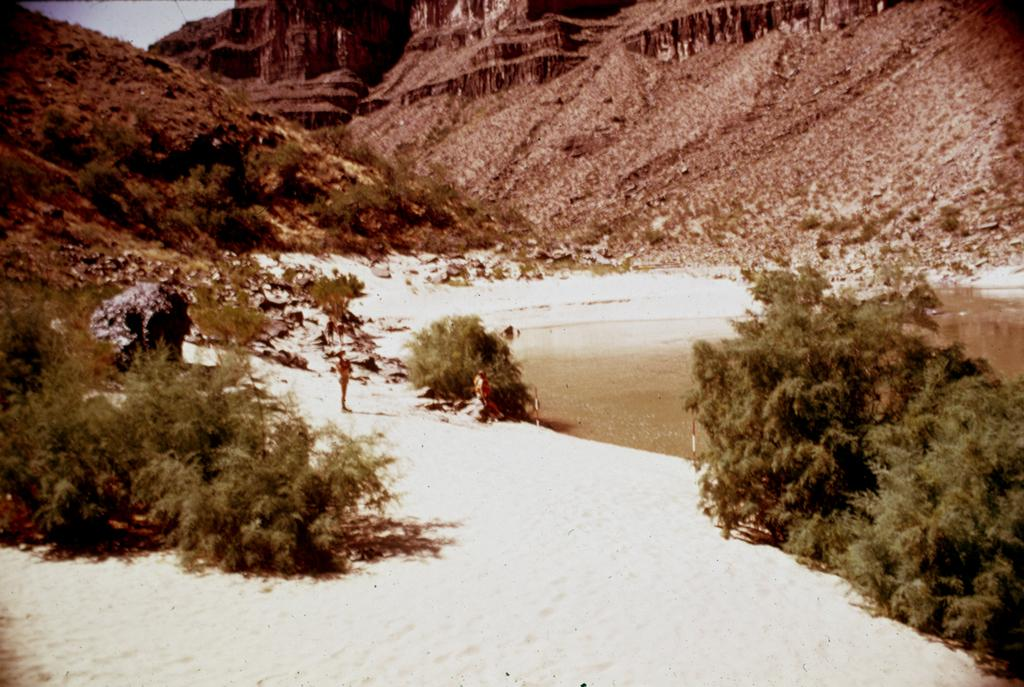What type of weather condition is depicted in the image? There is snow on the surface in the image, indicating a snowy or wintry condition. What can be seen on the right side of the image? There are trees on the right side of the image. What can be seen on the left side of the image? There are trees on the left side of the image as well. What is visible in the background of the image? There are hills and the sky visible in the background of the image. What type of stitch is used to sew the letters on the person's shirt in the image? There is no person or shirt present in the image; it features snow, trees, hills, and the sky. 